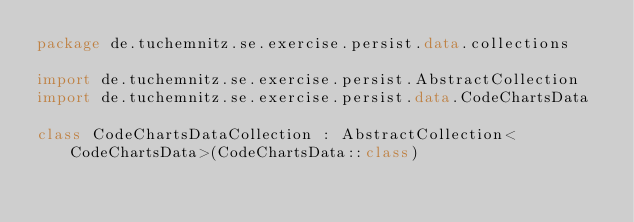<code> <loc_0><loc_0><loc_500><loc_500><_Kotlin_>package de.tuchemnitz.se.exercise.persist.data.collections

import de.tuchemnitz.se.exercise.persist.AbstractCollection
import de.tuchemnitz.se.exercise.persist.data.CodeChartsData

class CodeChartsDataCollection : AbstractCollection<CodeChartsData>(CodeChartsData::class)
</code> 